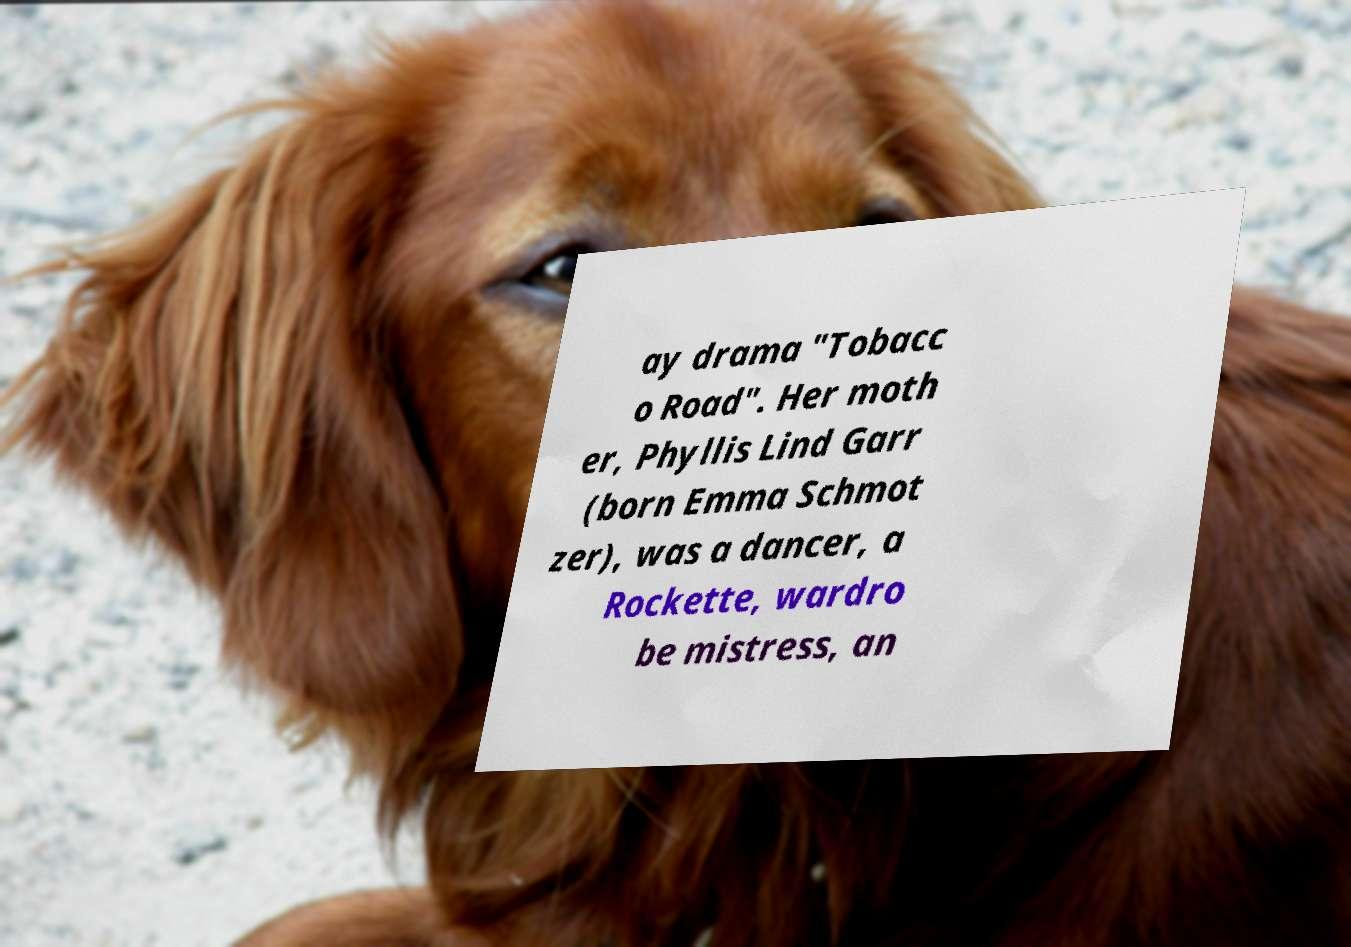Please identify and transcribe the text found in this image. ay drama "Tobacc o Road". Her moth er, Phyllis Lind Garr (born Emma Schmot zer), was a dancer, a Rockette, wardro be mistress, an 